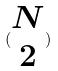<formula> <loc_0><loc_0><loc_500><loc_500>( \begin{matrix} N \\ 2 \end{matrix} )</formula> 